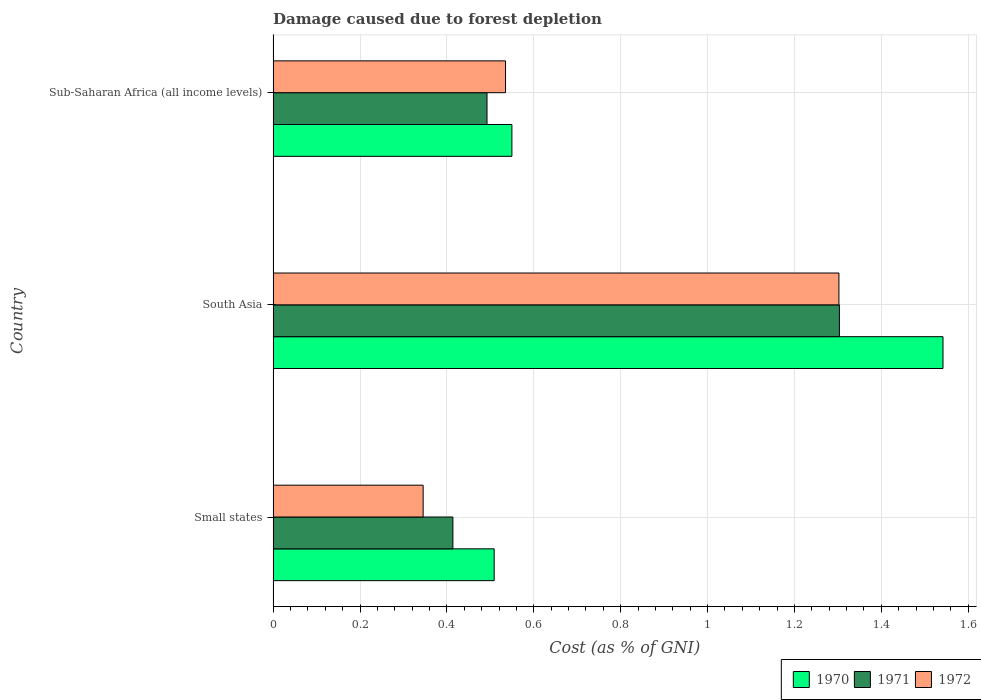How many different coloured bars are there?
Keep it short and to the point. 3. How many bars are there on the 1st tick from the bottom?
Your response must be concise. 3. What is the label of the 2nd group of bars from the top?
Give a very brief answer. South Asia. What is the cost of damage caused due to forest depletion in 1972 in Small states?
Give a very brief answer. 0.35. Across all countries, what is the maximum cost of damage caused due to forest depletion in 1972?
Give a very brief answer. 1.3. Across all countries, what is the minimum cost of damage caused due to forest depletion in 1972?
Make the answer very short. 0.35. In which country was the cost of damage caused due to forest depletion in 1972 minimum?
Keep it short and to the point. Small states. What is the total cost of damage caused due to forest depletion in 1972 in the graph?
Give a very brief answer. 2.18. What is the difference between the cost of damage caused due to forest depletion in 1970 in South Asia and that in Sub-Saharan Africa (all income levels)?
Your answer should be compact. 0.99. What is the difference between the cost of damage caused due to forest depletion in 1971 in South Asia and the cost of damage caused due to forest depletion in 1972 in Small states?
Your answer should be compact. 0.96. What is the average cost of damage caused due to forest depletion in 1971 per country?
Provide a succinct answer. 0.74. What is the difference between the cost of damage caused due to forest depletion in 1970 and cost of damage caused due to forest depletion in 1972 in Small states?
Your answer should be compact. 0.16. In how many countries, is the cost of damage caused due to forest depletion in 1971 greater than 1.3200000000000003 %?
Offer a very short reply. 0. What is the ratio of the cost of damage caused due to forest depletion in 1972 in Small states to that in Sub-Saharan Africa (all income levels)?
Keep it short and to the point. 0.65. Is the cost of damage caused due to forest depletion in 1972 in Small states less than that in South Asia?
Your response must be concise. Yes. What is the difference between the highest and the second highest cost of damage caused due to forest depletion in 1970?
Ensure brevity in your answer.  0.99. What is the difference between the highest and the lowest cost of damage caused due to forest depletion in 1971?
Give a very brief answer. 0.89. In how many countries, is the cost of damage caused due to forest depletion in 1972 greater than the average cost of damage caused due to forest depletion in 1972 taken over all countries?
Make the answer very short. 1. What does the 3rd bar from the bottom in Sub-Saharan Africa (all income levels) represents?
Ensure brevity in your answer.  1972. How many bars are there?
Your response must be concise. 9. What is the difference between two consecutive major ticks on the X-axis?
Provide a succinct answer. 0.2. Are the values on the major ticks of X-axis written in scientific E-notation?
Your response must be concise. No. Does the graph contain grids?
Offer a terse response. Yes. Where does the legend appear in the graph?
Provide a short and direct response. Bottom right. How many legend labels are there?
Offer a terse response. 3. What is the title of the graph?
Your response must be concise. Damage caused due to forest depletion. Does "1994" appear as one of the legend labels in the graph?
Provide a short and direct response. No. What is the label or title of the X-axis?
Provide a short and direct response. Cost (as % of GNI). What is the Cost (as % of GNI) in 1970 in Small states?
Keep it short and to the point. 0.51. What is the Cost (as % of GNI) in 1971 in Small states?
Your response must be concise. 0.41. What is the Cost (as % of GNI) in 1972 in Small states?
Provide a succinct answer. 0.35. What is the Cost (as % of GNI) in 1970 in South Asia?
Your response must be concise. 1.54. What is the Cost (as % of GNI) of 1971 in South Asia?
Provide a short and direct response. 1.3. What is the Cost (as % of GNI) of 1972 in South Asia?
Your response must be concise. 1.3. What is the Cost (as % of GNI) in 1970 in Sub-Saharan Africa (all income levels)?
Ensure brevity in your answer.  0.55. What is the Cost (as % of GNI) in 1971 in Sub-Saharan Africa (all income levels)?
Make the answer very short. 0.49. What is the Cost (as % of GNI) of 1972 in Sub-Saharan Africa (all income levels)?
Your response must be concise. 0.53. Across all countries, what is the maximum Cost (as % of GNI) of 1970?
Your answer should be compact. 1.54. Across all countries, what is the maximum Cost (as % of GNI) of 1971?
Provide a short and direct response. 1.3. Across all countries, what is the maximum Cost (as % of GNI) in 1972?
Give a very brief answer. 1.3. Across all countries, what is the minimum Cost (as % of GNI) of 1970?
Provide a succinct answer. 0.51. Across all countries, what is the minimum Cost (as % of GNI) of 1971?
Provide a short and direct response. 0.41. Across all countries, what is the minimum Cost (as % of GNI) of 1972?
Your answer should be compact. 0.35. What is the total Cost (as % of GNI) of 1970 in the graph?
Your response must be concise. 2.6. What is the total Cost (as % of GNI) of 1971 in the graph?
Ensure brevity in your answer.  2.21. What is the total Cost (as % of GNI) of 1972 in the graph?
Offer a terse response. 2.18. What is the difference between the Cost (as % of GNI) of 1970 in Small states and that in South Asia?
Your response must be concise. -1.03. What is the difference between the Cost (as % of GNI) in 1971 in Small states and that in South Asia?
Your response must be concise. -0.89. What is the difference between the Cost (as % of GNI) of 1972 in Small states and that in South Asia?
Give a very brief answer. -0.96. What is the difference between the Cost (as % of GNI) in 1970 in Small states and that in Sub-Saharan Africa (all income levels)?
Make the answer very short. -0.04. What is the difference between the Cost (as % of GNI) in 1971 in Small states and that in Sub-Saharan Africa (all income levels)?
Offer a very short reply. -0.08. What is the difference between the Cost (as % of GNI) of 1972 in Small states and that in Sub-Saharan Africa (all income levels)?
Provide a short and direct response. -0.19. What is the difference between the Cost (as % of GNI) of 1970 in South Asia and that in Sub-Saharan Africa (all income levels)?
Your response must be concise. 0.99. What is the difference between the Cost (as % of GNI) of 1971 in South Asia and that in Sub-Saharan Africa (all income levels)?
Give a very brief answer. 0.81. What is the difference between the Cost (as % of GNI) of 1972 in South Asia and that in Sub-Saharan Africa (all income levels)?
Keep it short and to the point. 0.77. What is the difference between the Cost (as % of GNI) in 1970 in Small states and the Cost (as % of GNI) in 1971 in South Asia?
Provide a succinct answer. -0.79. What is the difference between the Cost (as % of GNI) of 1970 in Small states and the Cost (as % of GNI) of 1972 in South Asia?
Offer a very short reply. -0.79. What is the difference between the Cost (as % of GNI) in 1971 in Small states and the Cost (as % of GNI) in 1972 in South Asia?
Offer a very short reply. -0.89. What is the difference between the Cost (as % of GNI) in 1970 in Small states and the Cost (as % of GNI) in 1971 in Sub-Saharan Africa (all income levels)?
Ensure brevity in your answer.  0.02. What is the difference between the Cost (as % of GNI) of 1970 in Small states and the Cost (as % of GNI) of 1972 in Sub-Saharan Africa (all income levels)?
Your answer should be compact. -0.03. What is the difference between the Cost (as % of GNI) of 1971 in Small states and the Cost (as % of GNI) of 1972 in Sub-Saharan Africa (all income levels)?
Your answer should be compact. -0.12. What is the difference between the Cost (as % of GNI) in 1970 in South Asia and the Cost (as % of GNI) in 1971 in Sub-Saharan Africa (all income levels)?
Your answer should be compact. 1.05. What is the difference between the Cost (as % of GNI) of 1970 in South Asia and the Cost (as % of GNI) of 1972 in Sub-Saharan Africa (all income levels)?
Offer a very short reply. 1.01. What is the difference between the Cost (as % of GNI) of 1971 in South Asia and the Cost (as % of GNI) of 1972 in Sub-Saharan Africa (all income levels)?
Offer a terse response. 0.77. What is the average Cost (as % of GNI) in 1970 per country?
Make the answer very short. 0.87. What is the average Cost (as % of GNI) in 1971 per country?
Provide a short and direct response. 0.74. What is the average Cost (as % of GNI) of 1972 per country?
Provide a short and direct response. 0.73. What is the difference between the Cost (as % of GNI) in 1970 and Cost (as % of GNI) in 1971 in Small states?
Give a very brief answer. 0.1. What is the difference between the Cost (as % of GNI) in 1970 and Cost (as % of GNI) in 1972 in Small states?
Your response must be concise. 0.16. What is the difference between the Cost (as % of GNI) in 1971 and Cost (as % of GNI) in 1972 in Small states?
Offer a terse response. 0.07. What is the difference between the Cost (as % of GNI) in 1970 and Cost (as % of GNI) in 1971 in South Asia?
Your answer should be compact. 0.24. What is the difference between the Cost (as % of GNI) of 1970 and Cost (as % of GNI) of 1972 in South Asia?
Provide a succinct answer. 0.24. What is the difference between the Cost (as % of GNI) of 1971 and Cost (as % of GNI) of 1972 in South Asia?
Provide a succinct answer. 0. What is the difference between the Cost (as % of GNI) in 1970 and Cost (as % of GNI) in 1971 in Sub-Saharan Africa (all income levels)?
Ensure brevity in your answer.  0.06. What is the difference between the Cost (as % of GNI) in 1970 and Cost (as % of GNI) in 1972 in Sub-Saharan Africa (all income levels)?
Your answer should be very brief. 0.01. What is the difference between the Cost (as % of GNI) in 1971 and Cost (as % of GNI) in 1972 in Sub-Saharan Africa (all income levels)?
Your answer should be very brief. -0.04. What is the ratio of the Cost (as % of GNI) in 1970 in Small states to that in South Asia?
Your response must be concise. 0.33. What is the ratio of the Cost (as % of GNI) in 1971 in Small states to that in South Asia?
Make the answer very short. 0.32. What is the ratio of the Cost (as % of GNI) in 1972 in Small states to that in South Asia?
Your answer should be compact. 0.27. What is the ratio of the Cost (as % of GNI) in 1970 in Small states to that in Sub-Saharan Africa (all income levels)?
Ensure brevity in your answer.  0.93. What is the ratio of the Cost (as % of GNI) of 1971 in Small states to that in Sub-Saharan Africa (all income levels)?
Your answer should be compact. 0.84. What is the ratio of the Cost (as % of GNI) of 1972 in Small states to that in Sub-Saharan Africa (all income levels)?
Provide a succinct answer. 0.65. What is the ratio of the Cost (as % of GNI) of 1970 in South Asia to that in Sub-Saharan Africa (all income levels)?
Offer a terse response. 2.81. What is the ratio of the Cost (as % of GNI) of 1971 in South Asia to that in Sub-Saharan Africa (all income levels)?
Your answer should be very brief. 2.65. What is the ratio of the Cost (as % of GNI) in 1972 in South Asia to that in Sub-Saharan Africa (all income levels)?
Offer a terse response. 2.43. What is the difference between the highest and the second highest Cost (as % of GNI) of 1971?
Give a very brief answer. 0.81. What is the difference between the highest and the second highest Cost (as % of GNI) of 1972?
Make the answer very short. 0.77. What is the difference between the highest and the lowest Cost (as % of GNI) in 1970?
Provide a short and direct response. 1.03. What is the difference between the highest and the lowest Cost (as % of GNI) of 1971?
Offer a very short reply. 0.89. What is the difference between the highest and the lowest Cost (as % of GNI) of 1972?
Offer a very short reply. 0.96. 